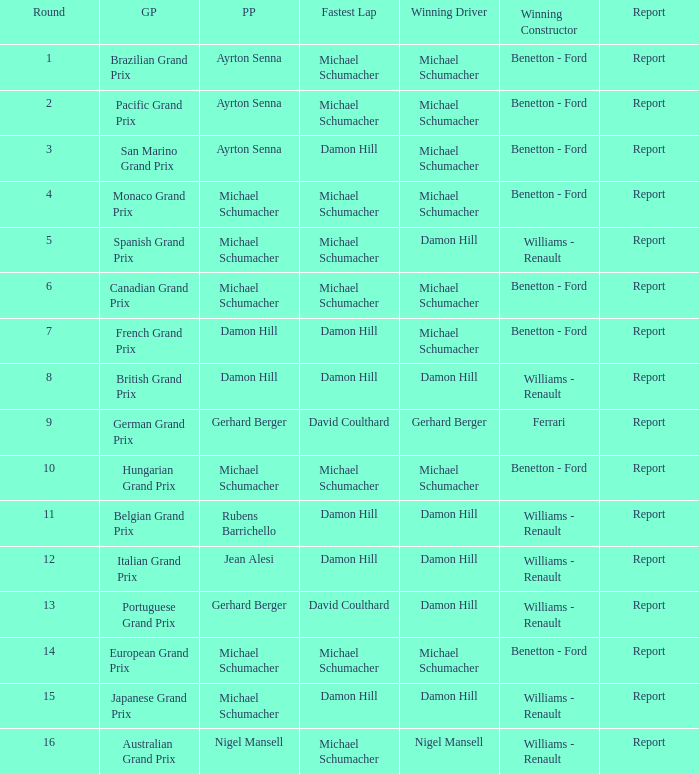Name the fastest lap for the brazilian grand prix Michael Schumacher. 